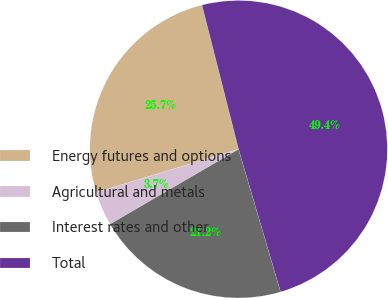<chart> <loc_0><loc_0><loc_500><loc_500><pie_chart><fcel>Energy futures and options<fcel>Agricultural and metals<fcel>Interest rates and other<fcel>Total<nl><fcel>25.73%<fcel>3.71%<fcel>21.16%<fcel>49.4%<nl></chart> 